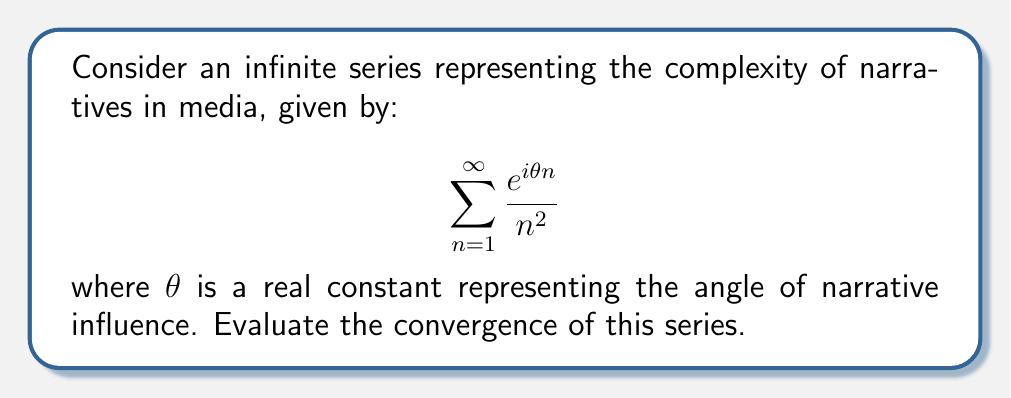What is the answer to this math problem? To evaluate the convergence of this series, we'll follow these steps:

1) First, note that this series is of the form of a Dirichlet series:

   $$\sum_{n=1}^{\infty} \frac{a_n}{n^s}$$

   where $a_n = e^{i\theta n}$ and $s = 2$.

2) For a Dirichlet series, if $|a_n| \leq M$ for some constant $M$ and for all $n$, then the series converges absolutely for $Re(s) > 1$.

3) In our case, $|a_n| = |e^{i\theta n}| = 1$ for all $n$ and any real $\theta$, because $|e^{ix}| = 1$ for any real $x$.

4) We have $s = 2$, which is real and greater than 1.

5) Therefore, the conditions for absolute convergence are satisfied.

6) Moreover, we can identify this series as a specific case of the polylogarithm function:

   $$Li_2(e^{i\theta}) = \sum_{n=1}^{\infty} \frac{e^{i\theta n}}{n^2}$$

7) The polylogarithm function $Li_2(z)$ is well-defined for $|z| \leq 1$, which is satisfied here as $|e^{i\theta}| = 1$.

Thus, we can conclude that this series converges for all real values of $\theta$.
Answer: The series converges for all real $\theta$. 